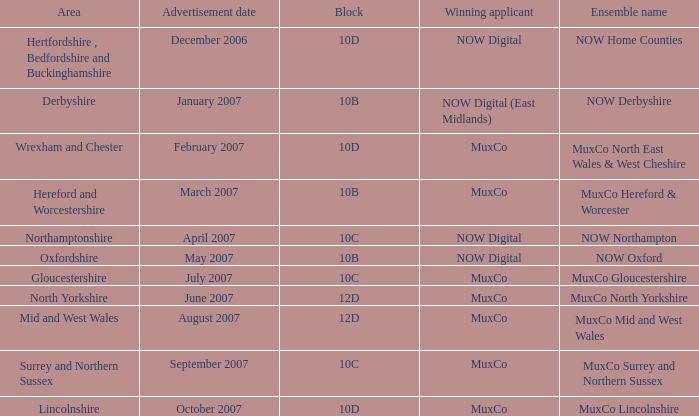What is Oxfordshire Area's Ensemble Name? NOW Oxford. Could you help me parse every detail presented in this table? {'header': ['Area', 'Advertisement date', 'Block', 'Winning applicant', 'Ensemble name'], 'rows': [['Hertfordshire , Bedfordshire and Buckinghamshire', 'December 2006', '10D', 'NOW Digital', 'NOW Home Counties'], ['Derbyshire', 'January 2007', '10B', 'NOW Digital (East Midlands)', 'NOW Derbyshire'], ['Wrexham and Chester', 'February 2007', '10D', 'MuxCo', 'MuxCo North East Wales & West Cheshire'], ['Hereford and Worcestershire', 'March 2007', '10B', 'MuxCo', 'MuxCo Hereford & Worcester'], ['Northamptonshire', 'April 2007', '10C', 'NOW Digital', 'NOW Northampton'], ['Oxfordshire', 'May 2007', '10B', 'NOW Digital', 'NOW Oxford'], ['Gloucestershire', 'July 2007', '10C', 'MuxCo', 'MuxCo Gloucestershire'], ['North Yorkshire', 'June 2007', '12D', 'MuxCo', 'MuxCo North Yorkshire'], ['Mid and West Wales', 'August 2007', '12D', 'MuxCo', 'MuxCo Mid and West Wales'], ['Surrey and Northern Sussex', 'September 2007', '10C', 'MuxCo', 'MuxCo Surrey and Northern Sussex'], ['Lincolnshire', 'October 2007', '10D', 'MuxCo', 'MuxCo Lincolnshire']]} 